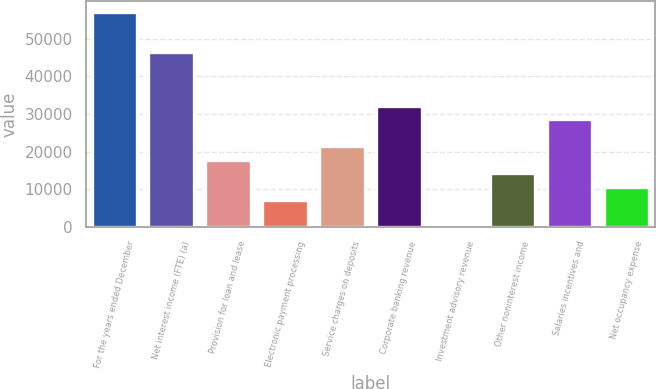<chart> <loc_0><loc_0><loc_500><loc_500><bar_chart><fcel>For the years ended December<fcel>Net interest income (FTE) (a)<fcel>Provision for loan and lease<fcel>Electronic payment processing<fcel>Service charges on deposits<fcel>Corporate banking revenue<fcel>Investment advisory revenue<fcel>Other noninterest income<fcel>Salaries incentives and<fcel>Net occupancy expense<nl><fcel>57063.8<fcel>46364.9<fcel>17834.5<fcel>7135.6<fcel>21400.8<fcel>32099.7<fcel>3<fcel>14268.2<fcel>28533.4<fcel>10701.9<nl></chart> 